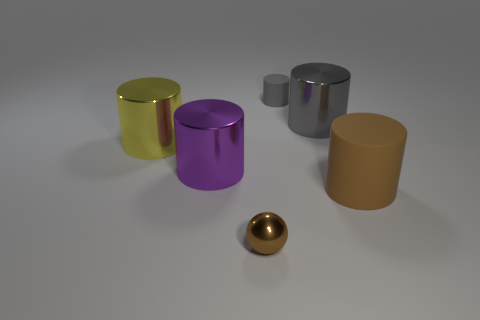Subtract all large brown cylinders. How many cylinders are left? 4 Subtract all purple cubes. How many gray cylinders are left? 2 Subtract 2 cylinders. How many cylinders are left? 3 Add 1 small gray rubber cylinders. How many objects exist? 7 Subtract all cylinders. How many objects are left? 1 Subtract all gray cylinders. How many cylinders are left? 3 Subtract all yellow cylinders. Subtract all cyan blocks. How many cylinders are left? 4 Subtract all tiny cylinders. Subtract all gray cylinders. How many objects are left? 3 Add 5 small gray rubber cylinders. How many small gray rubber cylinders are left? 6 Add 4 big metallic things. How many big metallic things exist? 7 